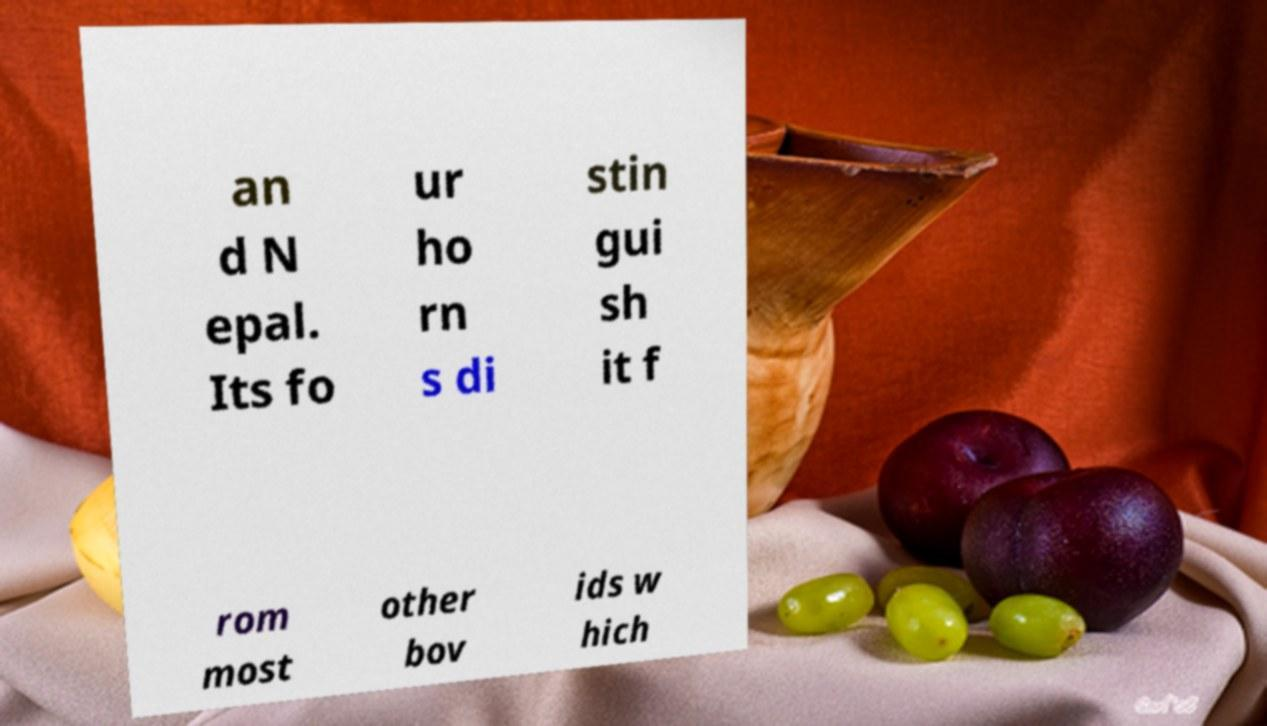Could you assist in decoding the text presented in this image and type it out clearly? an d N epal. Its fo ur ho rn s di stin gui sh it f rom most other bov ids w hich 